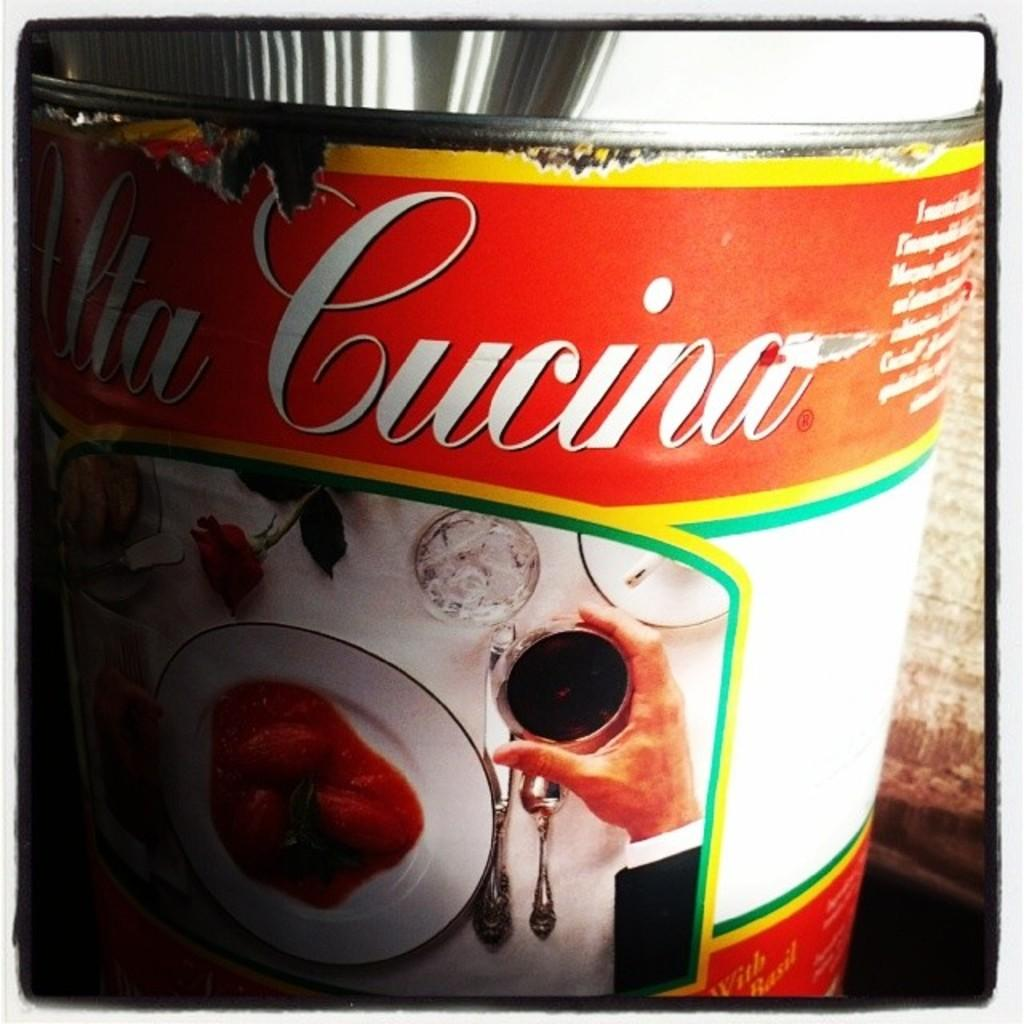<image>
Create a compact narrative representing the image presented. a cucino can that has white writing on it 